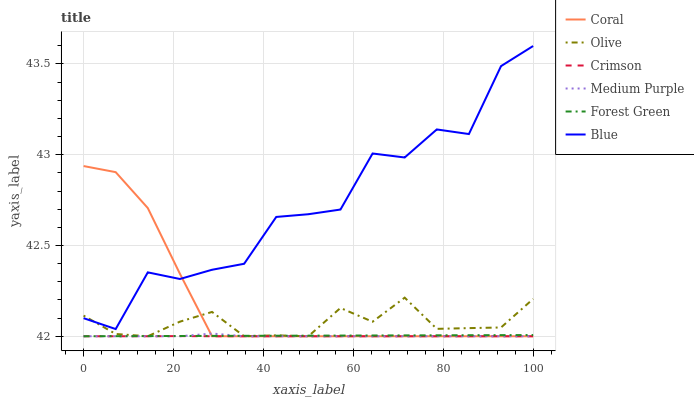Does Crimson have the minimum area under the curve?
Answer yes or no. Yes. Does Blue have the maximum area under the curve?
Answer yes or no. Yes. Does Coral have the minimum area under the curve?
Answer yes or no. No. Does Coral have the maximum area under the curve?
Answer yes or no. No. Is Forest Green the smoothest?
Answer yes or no. Yes. Is Blue the roughest?
Answer yes or no. Yes. Is Coral the smoothest?
Answer yes or no. No. Is Coral the roughest?
Answer yes or no. No. Does Coral have the lowest value?
Answer yes or no. Yes. Does Blue have the highest value?
Answer yes or no. Yes. Does Coral have the highest value?
Answer yes or no. No. Is Crimson less than Blue?
Answer yes or no. Yes. Is Blue greater than Medium Purple?
Answer yes or no. Yes. Does Forest Green intersect Coral?
Answer yes or no. Yes. Is Forest Green less than Coral?
Answer yes or no. No. Is Forest Green greater than Coral?
Answer yes or no. No. Does Crimson intersect Blue?
Answer yes or no. No. 